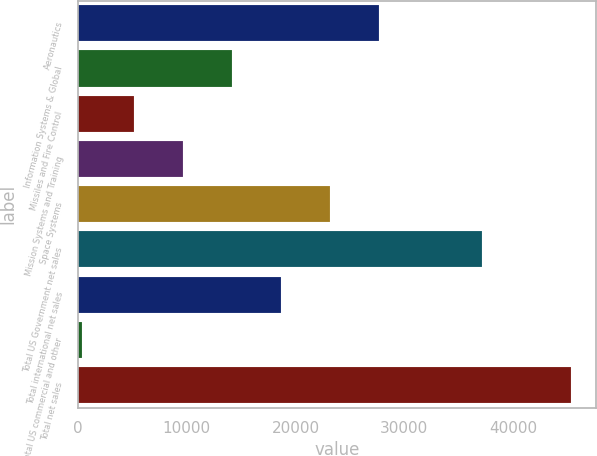<chart> <loc_0><loc_0><loc_500><loc_500><bar_chart><fcel>Aeronautics<fcel>Information Systems & Global<fcel>Missiles and Fire Control<fcel>Mission Systems and Training<fcel>Space Systems<fcel>Total US Government net sales<fcel>Total international net sales<fcel>Total US commercial and other<fcel>Total net sales<nl><fcel>27647.5<fcel>14165.2<fcel>5177<fcel>9671.1<fcel>23153.4<fcel>37173<fcel>18659.3<fcel>417<fcel>45358<nl></chart> 